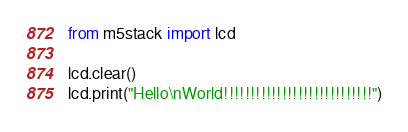<code> <loc_0><loc_0><loc_500><loc_500><_Python_>from m5stack import lcd

lcd.clear()
lcd.print("Hello\nWorld!!!!!!!!!!!!!!!!!!!!!!!!!!!!")
</code> 